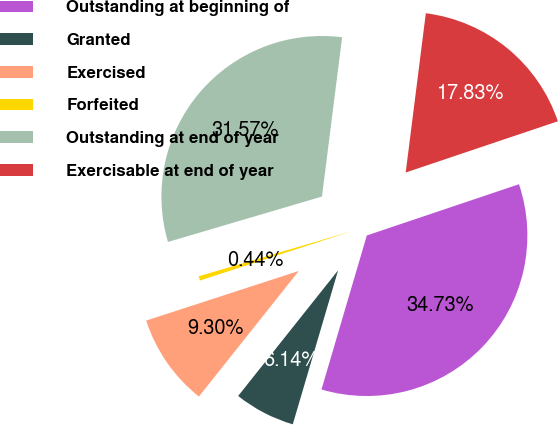Convert chart. <chart><loc_0><loc_0><loc_500><loc_500><pie_chart><fcel>Outstanding at beginning of<fcel>Granted<fcel>Exercised<fcel>Forfeited<fcel>Outstanding at end of year<fcel>Exercisable at end of year<nl><fcel>34.73%<fcel>6.14%<fcel>9.3%<fcel>0.44%<fcel>31.57%<fcel>17.83%<nl></chart> 